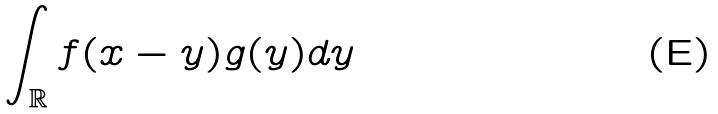<formula> <loc_0><loc_0><loc_500><loc_500>\int _ { \mathbb { R } } f ( x - y ) g ( y ) d y</formula> 